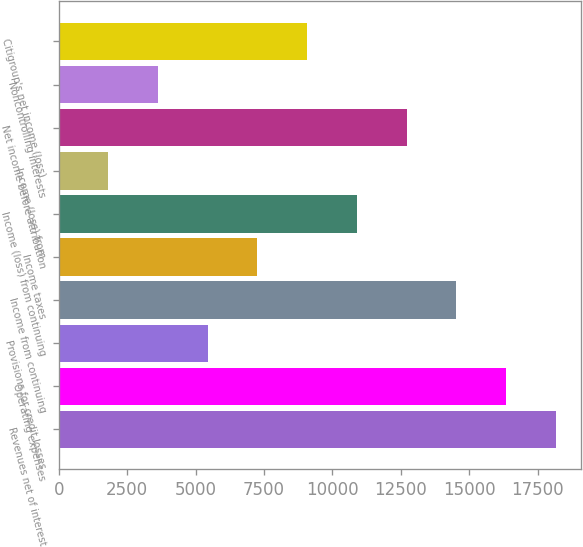<chart> <loc_0><loc_0><loc_500><loc_500><bar_chart><fcel>Revenues net of interest<fcel>Operating expenses<fcel>Provisions for credit losses<fcel>Income from continuing<fcel>Income taxes<fcel>Income (loss) from continuing<fcel>Income (loss) from<fcel>Net income before attribution<fcel>Noncontrolling interests<fcel>Citigroup's net income (loss)<nl><fcel>18155<fcel>16339.6<fcel>5447.39<fcel>14524.2<fcel>7262.76<fcel>10893.5<fcel>1816.65<fcel>12708.9<fcel>3632.02<fcel>9078.13<nl></chart> 